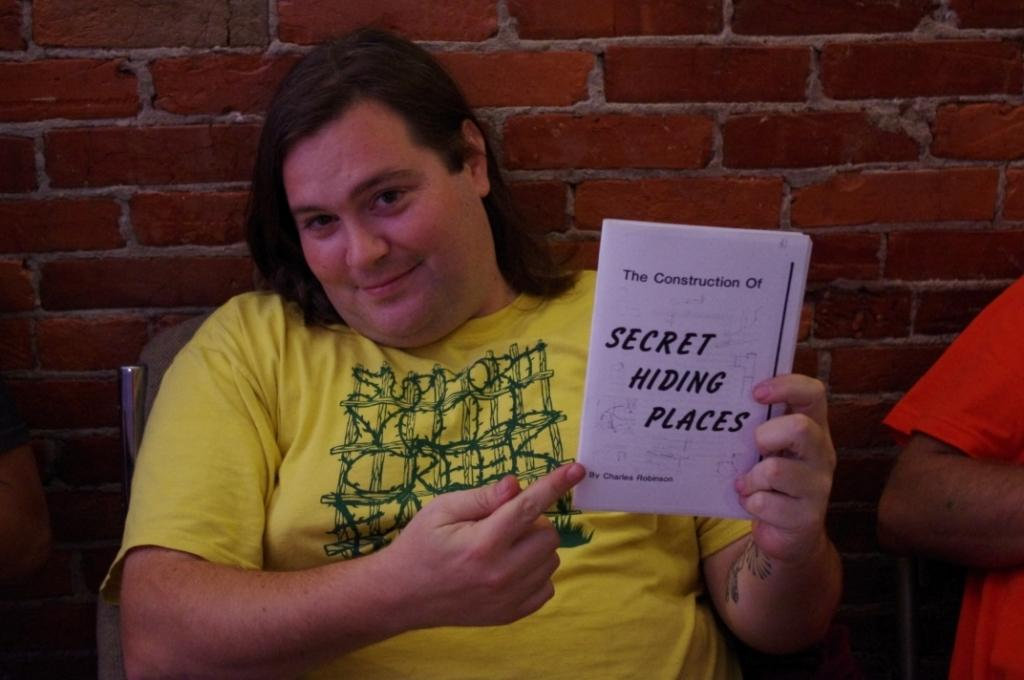<image>
Present a compact description of the photo's key features. A man holding a book titled Secret Hiding Places. 